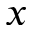Convert formula to latex. <formula><loc_0><loc_0><loc_500><loc_500>x</formula> 